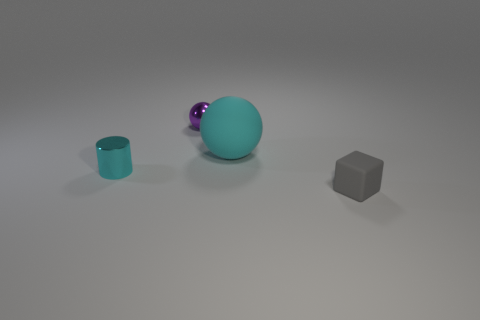Are there any other things that are the same size as the cyan matte object?
Keep it short and to the point. No. There is a rubber thing that is left of the tiny rubber thing; what size is it?
Keep it short and to the point. Large. Are there any cyan balls to the right of the gray thing?
Provide a short and direct response. No. Are there an equal number of tiny purple shiny objects that are to the left of the small ball and purple metal spheres?
Give a very brief answer. No. Are there any tiny objects that are in front of the cyan object that is on the left side of the rubber object that is on the left side of the small gray rubber object?
Give a very brief answer. Yes. What is the material of the big cyan ball?
Ensure brevity in your answer.  Rubber. What number of other things are there of the same shape as the gray object?
Your response must be concise. 0. Is the large cyan rubber object the same shape as the small cyan thing?
Ensure brevity in your answer.  No. What number of objects are small shiny things that are to the right of the small metal cylinder or objects that are in front of the large object?
Provide a short and direct response. 3. How many objects are either big balls or small brown shiny cubes?
Offer a very short reply. 1. 